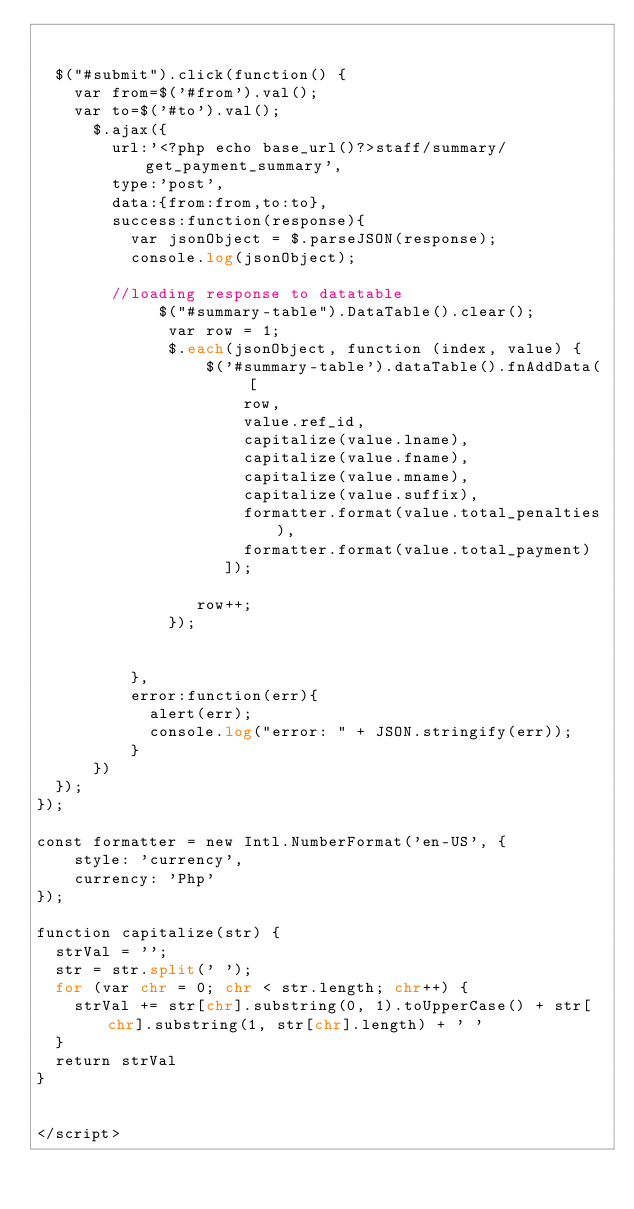Convert code to text. <code><loc_0><loc_0><loc_500><loc_500><_PHP_> 

  $("#submit").click(function() {
  	var from=$('#from').val();
  	var to=$('#to').val();
   		$.ajax({
   			url:'<?php echo base_url()?>staff/summary/get_payment_summary',
   			type:'post',
   			data:{from:from,to:to},
   			success:function(response){
   				var jsonObject = $.parseJSON(response);    				
   				console.log(jsonObject);

   			//loading response to datatable
   				   $("#summary-table").DataTable().clear();
			        var row = 1;
			        $.each(jsonObject, function (index, value) {
			            $('#summary-table').dataTable().fnAddData( [
			                row,
			                value.ref_id,
			                capitalize(value.lname),
			                capitalize(value.fname),			                
			                capitalize(value.mname),
			                capitalize(value.suffix),
			                formatter.format(value.total_penalties),
			                formatter.format(value.total_payment) 
			              ]);

			           row++;
			        });  				
   				

   				},
	   			error:function(err){
	   				alert(err);
	   				console.log("error: " + JSON.stringify(err));
	   			}	
   		})
  });
});

const formatter = new Intl.NumberFormat('en-US', {
    style: 'currency',
    currency: 'Php'
});

function capitalize(str) {
  strVal = '';
  str = str.split(' ');
  for (var chr = 0; chr < str.length; chr++) {
    strVal += str[chr].substring(0, 1).toUpperCase() + str[chr].substring(1, str[chr].length) + ' '
  }
  return strVal
}


</script></code> 